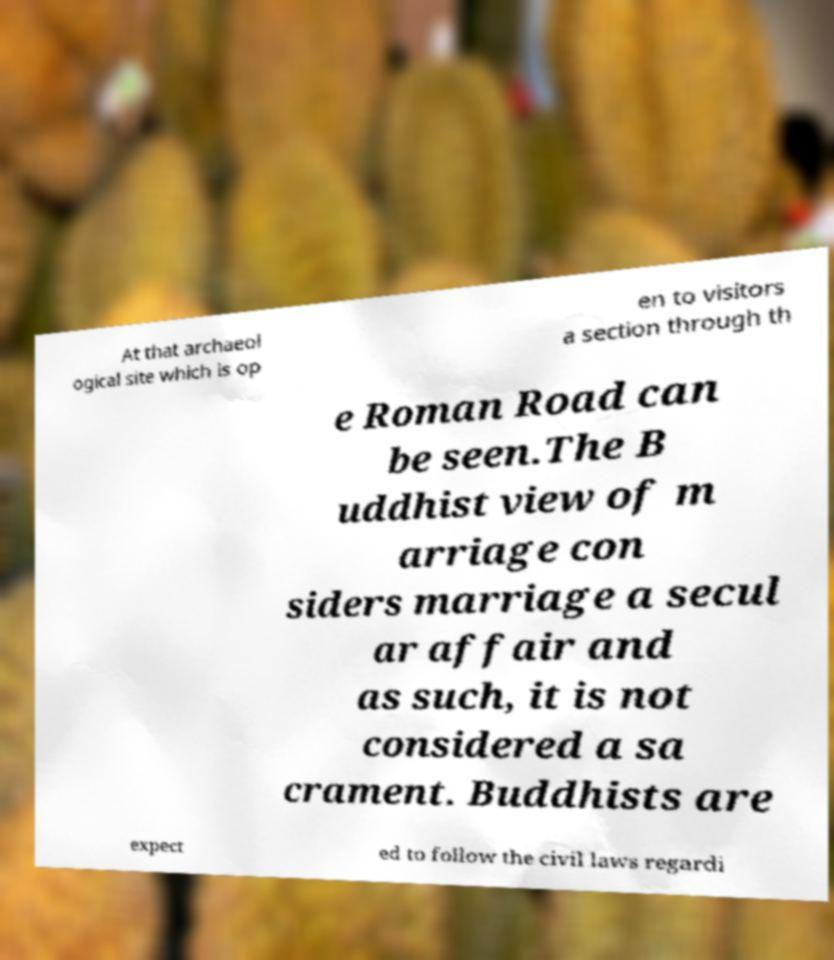Can you accurately transcribe the text from the provided image for me? At that archaeol ogical site which is op en to visitors a section through th e Roman Road can be seen.The B uddhist view of m arriage con siders marriage a secul ar affair and as such, it is not considered a sa crament. Buddhists are expect ed to follow the civil laws regardi 